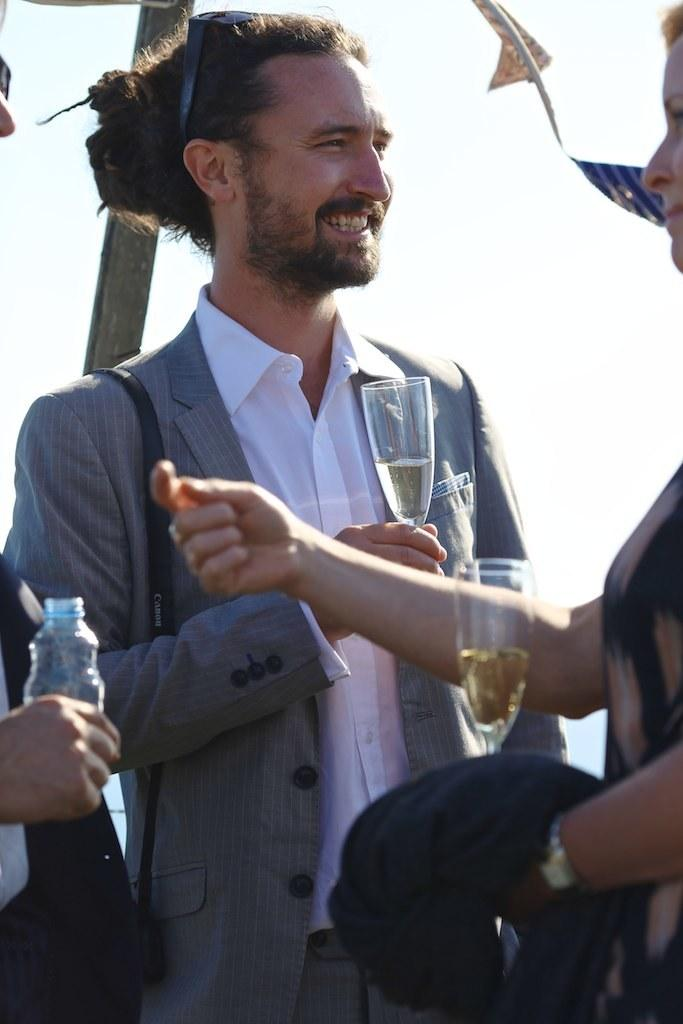Who is the main subject in the image? There is a man in the image. What is the man doing in the image? The man is standing and holding a wine glass in his hand. Are there any other people in the image? Yes, there are other people in the image. What are the other people doing in the image? The other people are standing and holding wine glasses in their hands. What type of plantation can be seen in the background of the image? There is no plantation visible in the image. How long did the snail take to reach the man in the image? There is no snail present in the image, so it is not possible to determine how long it would take for a snail to reach the man. 